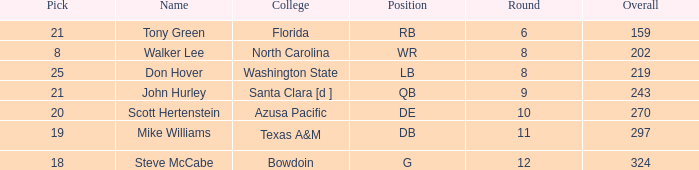What is the average overall that has a pick less than 20, North Carolina as the college, with a round less than 8? None. 